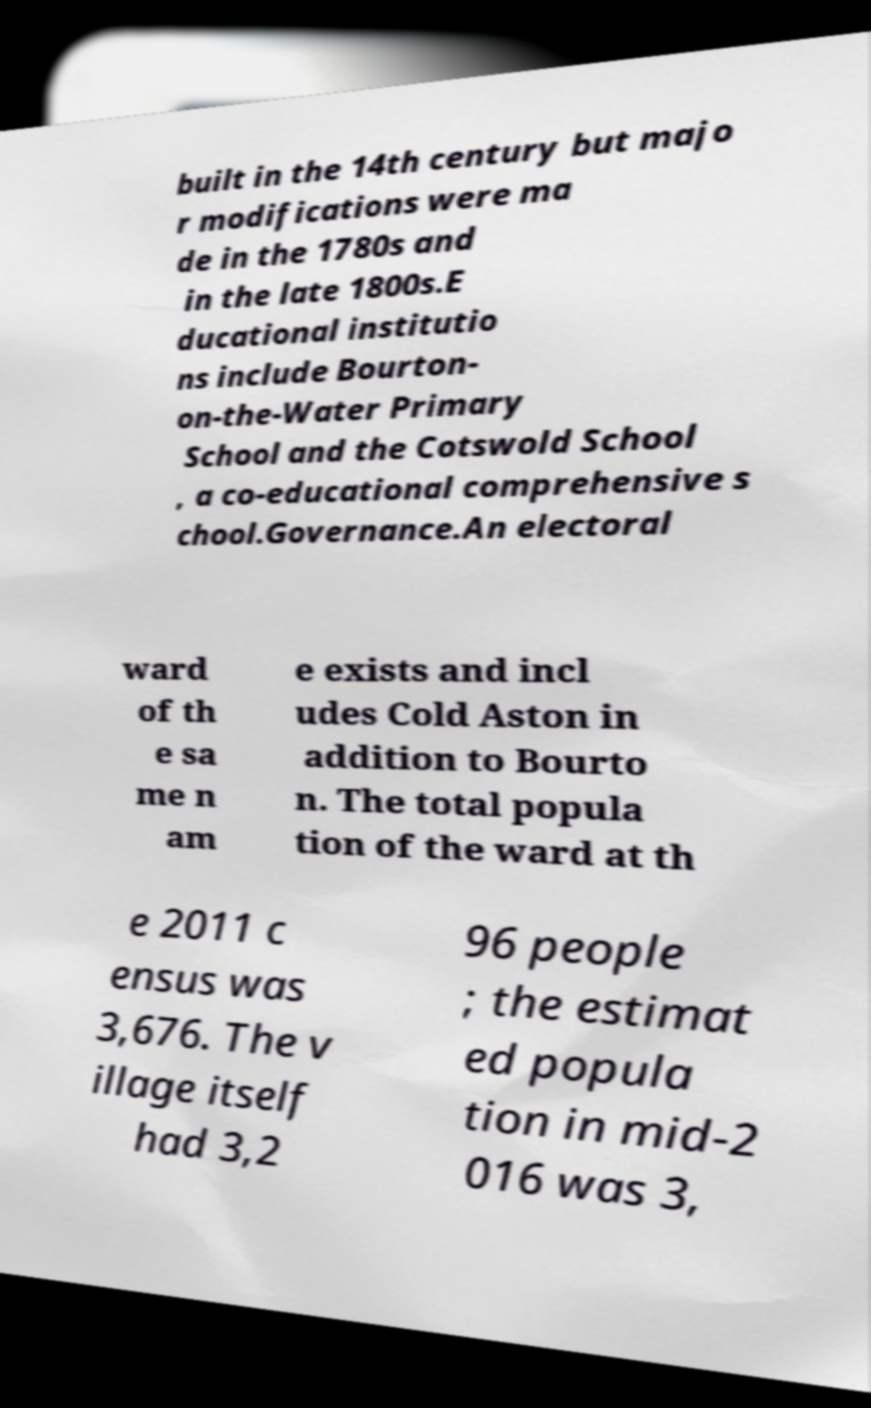Please identify and transcribe the text found in this image. built in the 14th century but majo r modifications were ma de in the 1780s and in the late 1800s.E ducational institutio ns include Bourton- on-the-Water Primary School and the Cotswold School , a co-educational comprehensive s chool.Governance.An electoral ward of th e sa me n am e exists and incl udes Cold Aston in addition to Bourto n. The total popula tion of the ward at th e 2011 c ensus was 3,676. The v illage itself had 3,2 96 people ; the estimat ed popula tion in mid-2 016 was 3, 